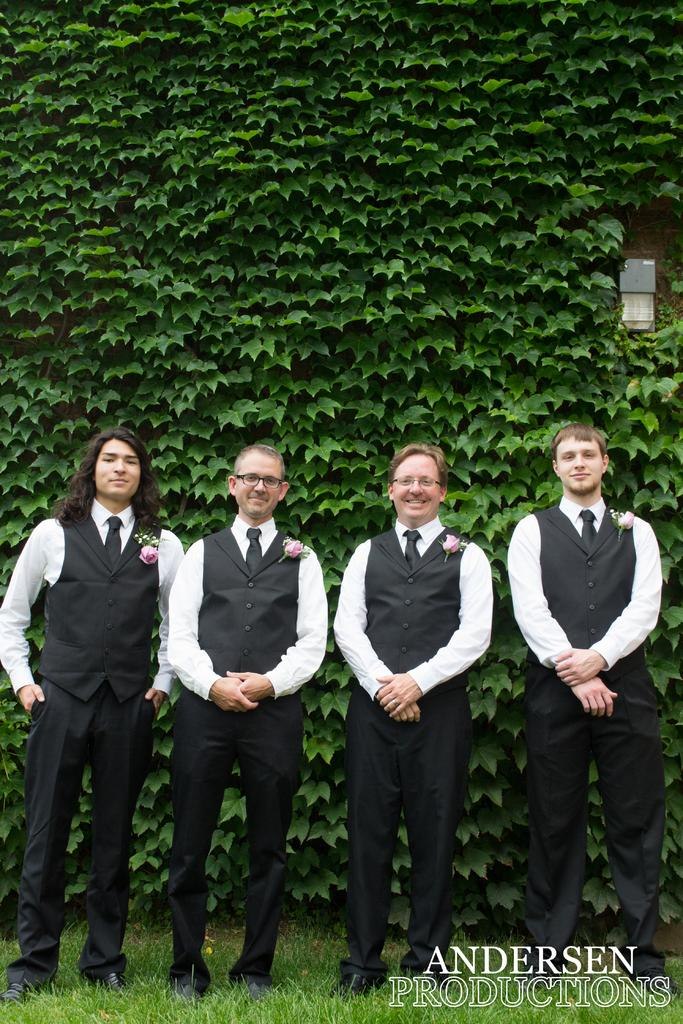Who or what is present in the image? There are people in the image. What colors are the dresses of the people wearing? The people are wearing white and black color dresses. What type of vegetation can be seen in the image? There are green leaves visible in the image. What is the ground surface like in the image? There is grass in the image. What type of glass is being used by the people in the image? There is no glass present in the image; the people are wearing dresses and standing on grass. 